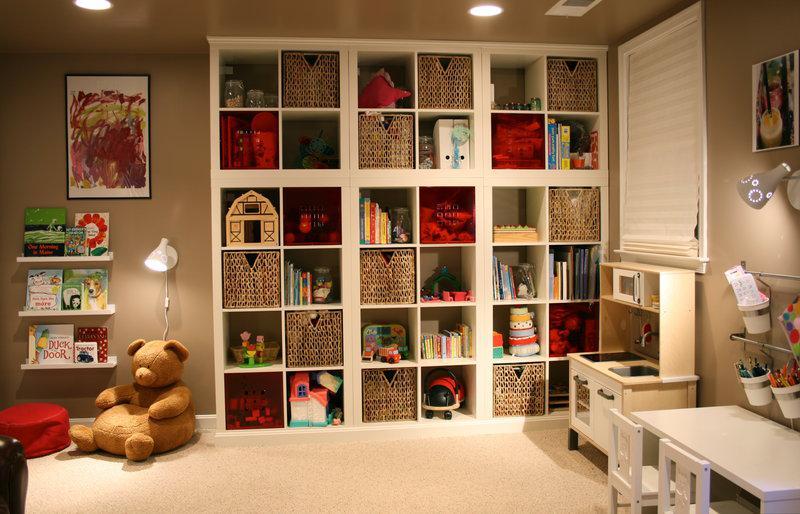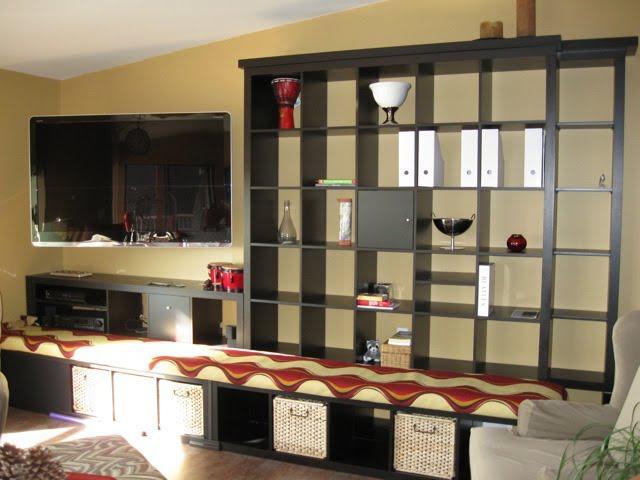The first image is the image on the left, the second image is the image on the right. For the images displayed, is the sentence "The wall-filling white shelf unit in the left image features multiple red squares." factually correct? Answer yes or no. Yes. The first image is the image on the left, the second image is the image on the right. Examine the images to the left and right. Is the description "there is a white bookshelf with a mirror hanging on it" accurate? Answer yes or no. No. 